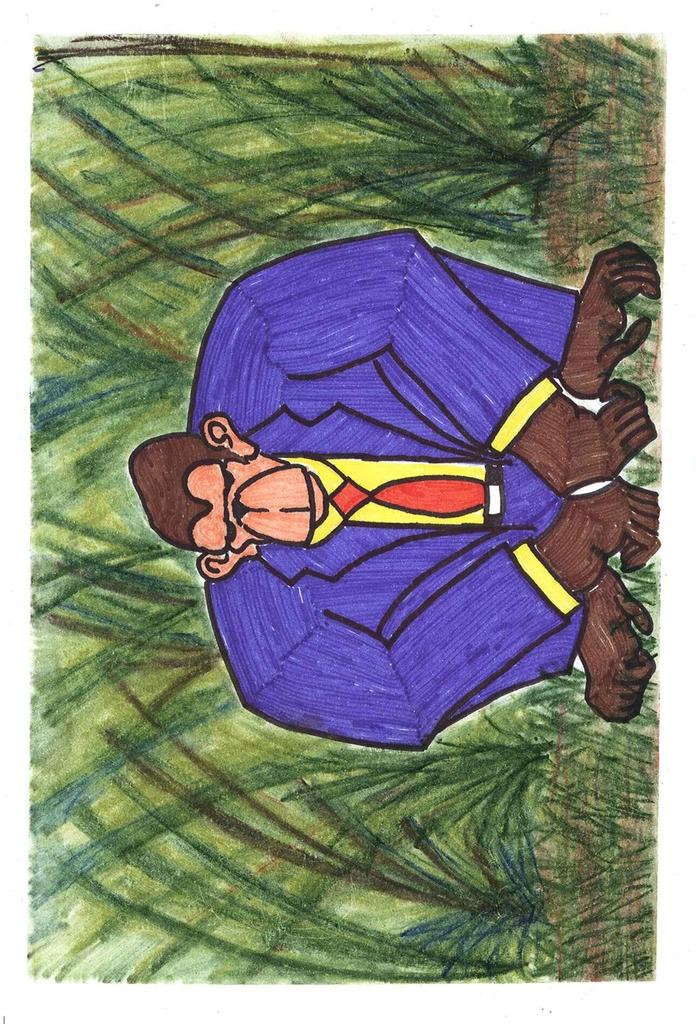What is the main subject of focus of the image? The image contains a drawing. What is depicted in the center of the drawing? There is a monkey in the center of the drawing. What can be seen in the background of the drawing? There are plants in the background of the drawing. What month is suggested by the drawing? The drawing does not suggest a specific month; it only depicts a monkey and plants in the background. 